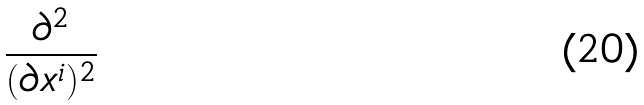Convert formula to latex. <formula><loc_0><loc_0><loc_500><loc_500>\frac { \partial ^ { 2 } } { ( \partial x ^ { i } ) ^ { 2 } }</formula> 